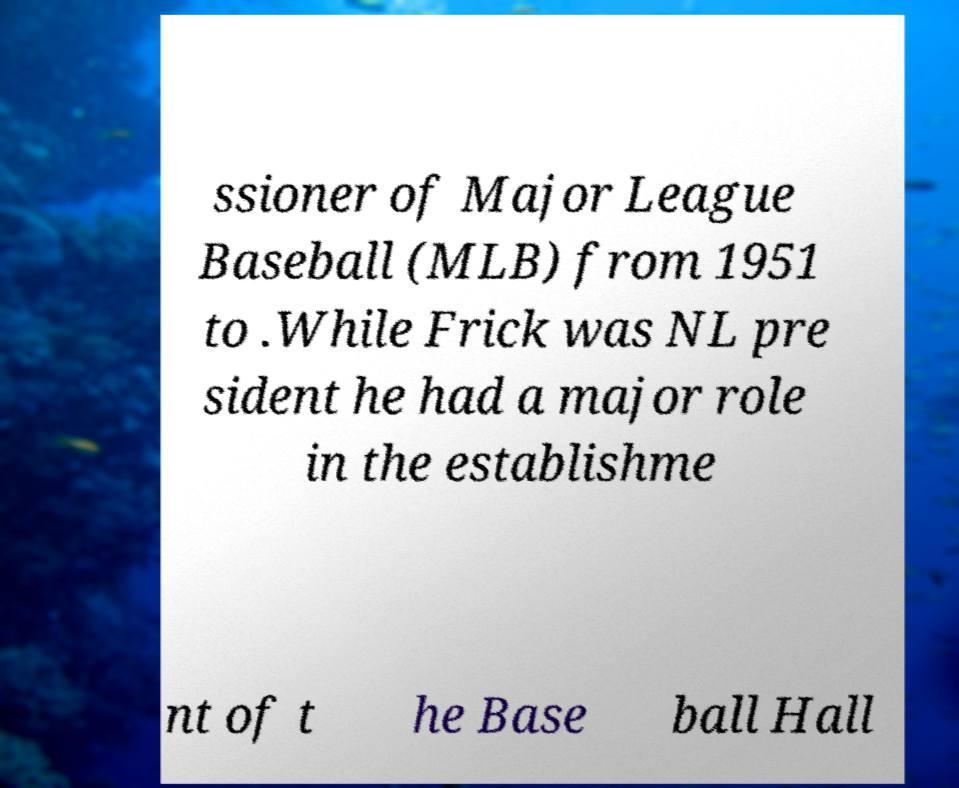Please read and relay the text visible in this image. What does it say? ssioner of Major League Baseball (MLB) from 1951 to .While Frick was NL pre sident he had a major role in the establishme nt of t he Base ball Hall 